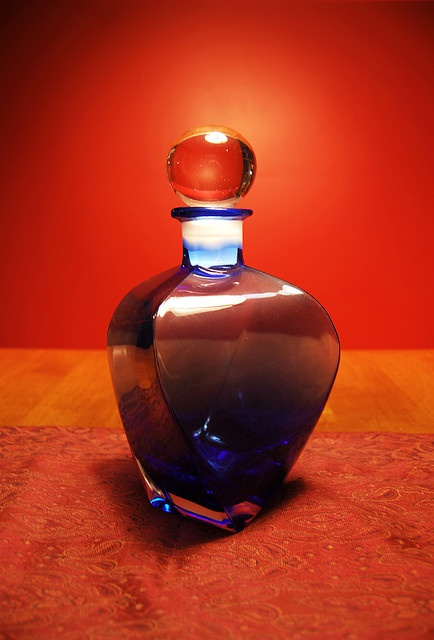Describe the objects in this image and their specific colors. I can see a bottle in black, maroon, brown, and white tones in this image. 